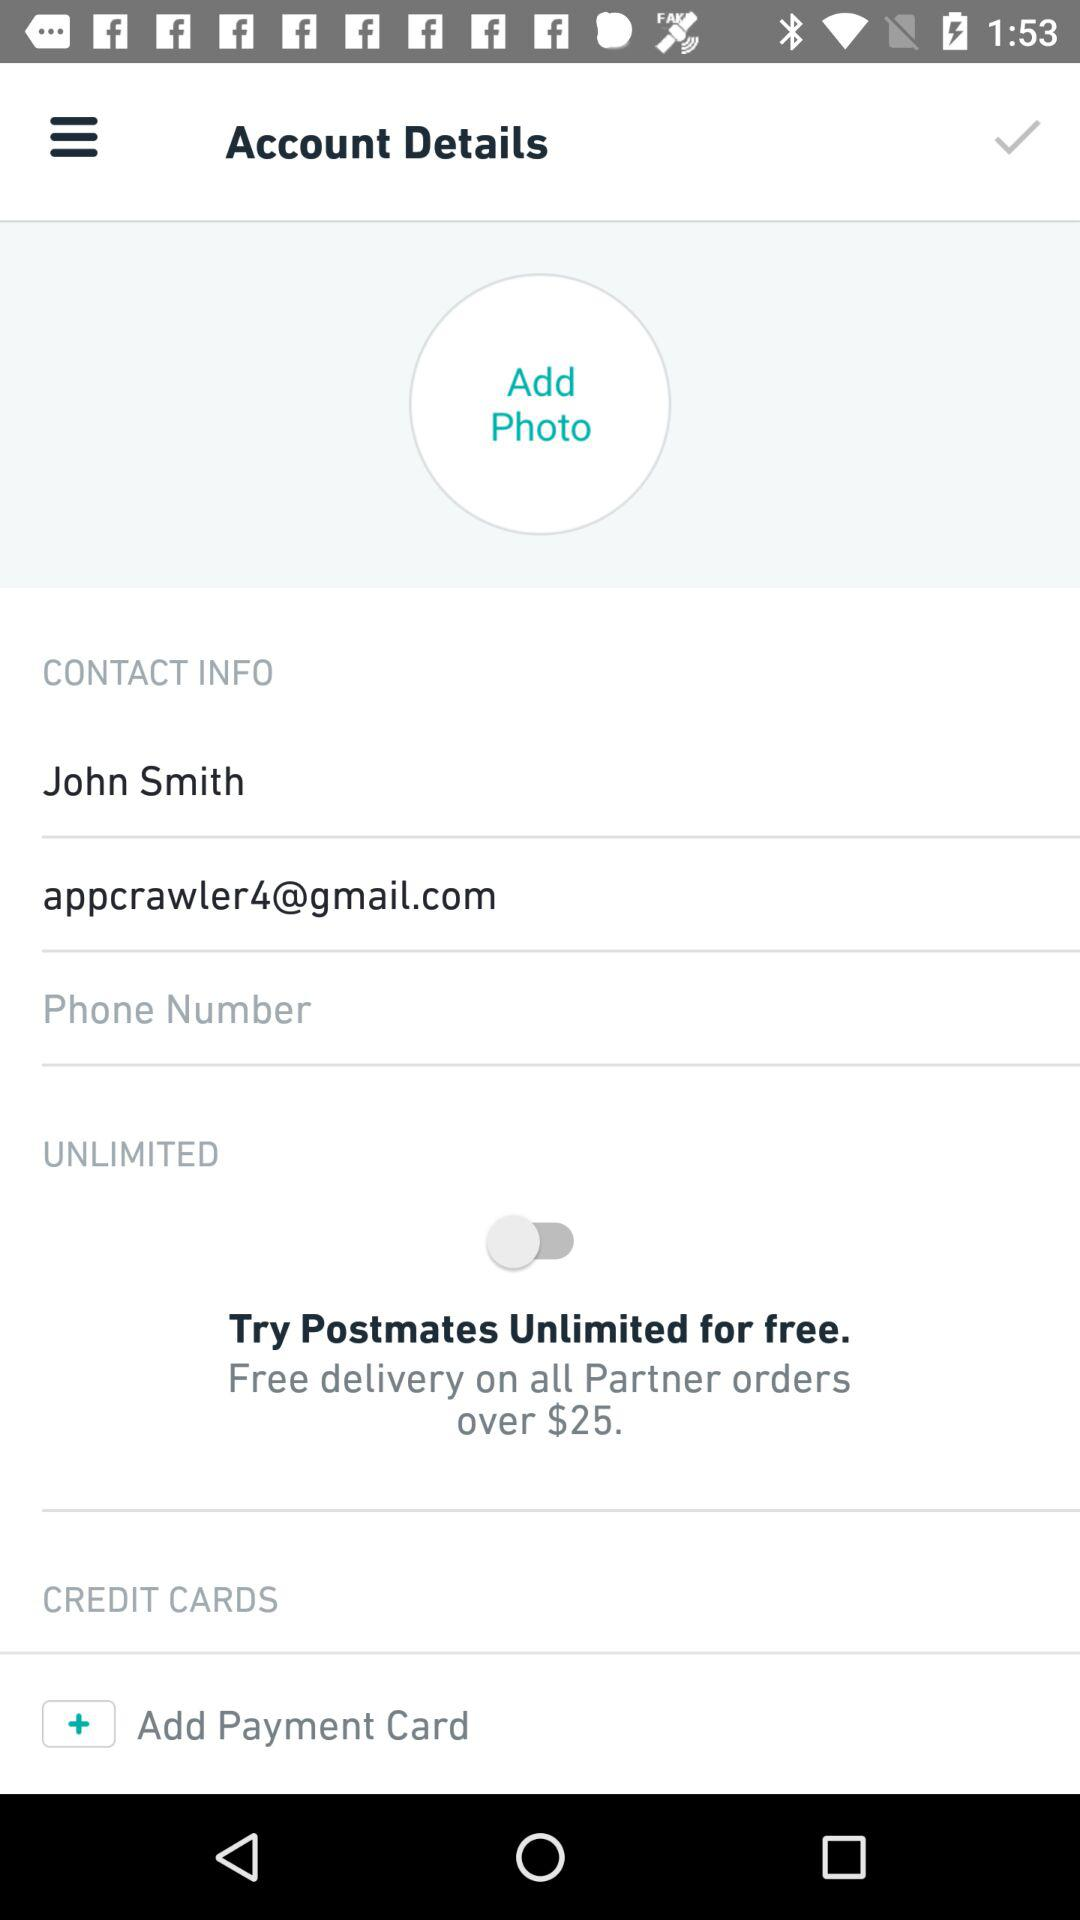What is the email address? The email address is appcrawler4@gmail.com. 